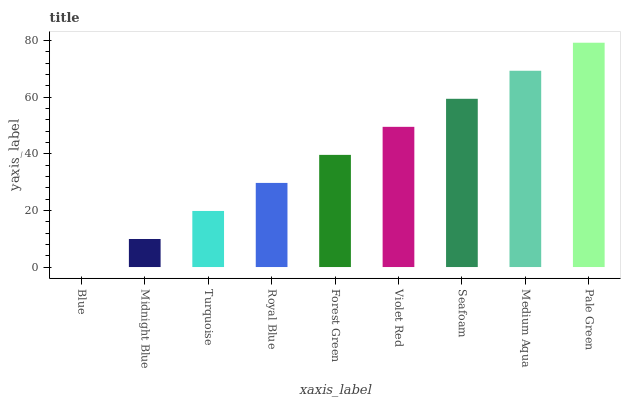Is Blue the minimum?
Answer yes or no. Yes. Is Pale Green the maximum?
Answer yes or no. Yes. Is Midnight Blue the minimum?
Answer yes or no. No. Is Midnight Blue the maximum?
Answer yes or no. No. Is Midnight Blue greater than Blue?
Answer yes or no. Yes. Is Blue less than Midnight Blue?
Answer yes or no. Yes. Is Blue greater than Midnight Blue?
Answer yes or no. No. Is Midnight Blue less than Blue?
Answer yes or no. No. Is Forest Green the high median?
Answer yes or no. Yes. Is Forest Green the low median?
Answer yes or no. Yes. Is Violet Red the high median?
Answer yes or no. No. Is Midnight Blue the low median?
Answer yes or no. No. 